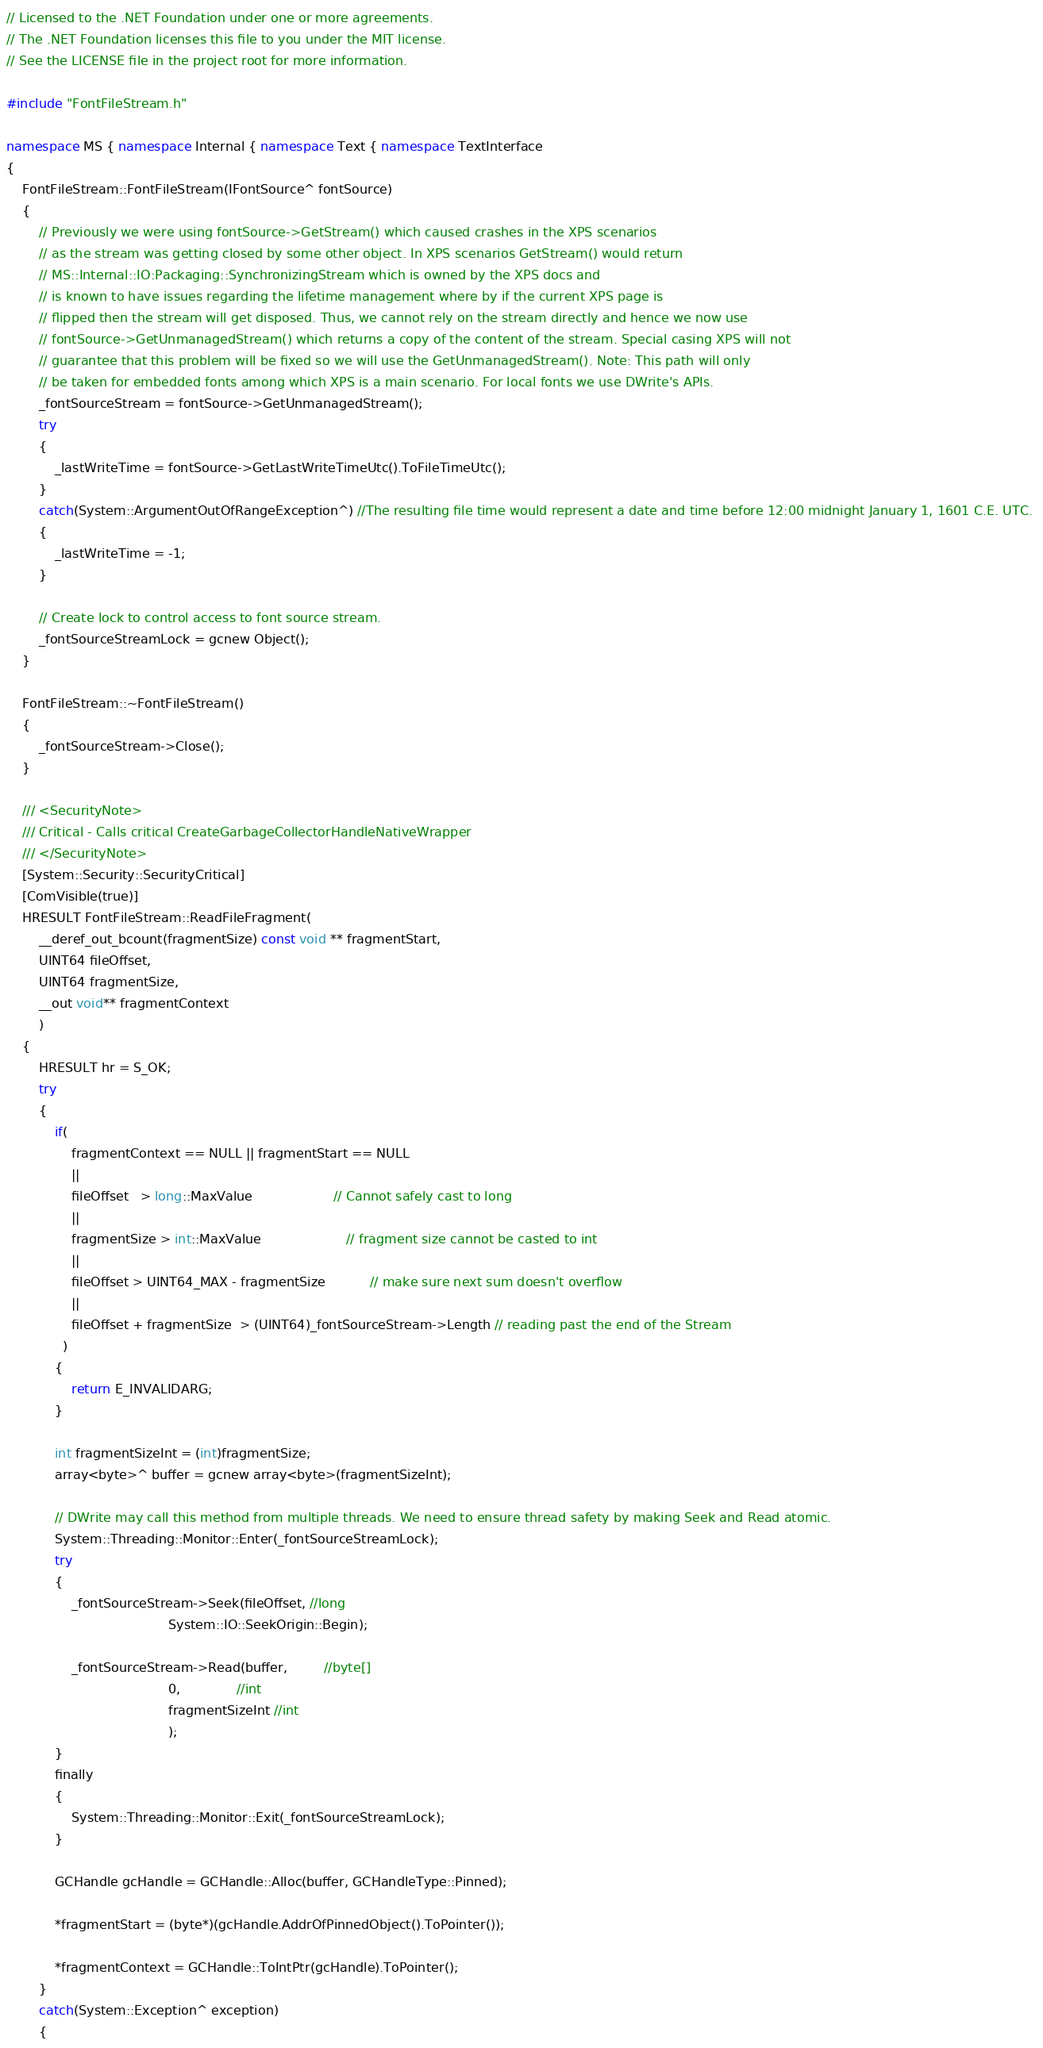<code> <loc_0><loc_0><loc_500><loc_500><_C++_>// Licensed to the .NET Foundation under one or more agreements.
// The .NET Foundation licenses this file to you under the MIT license.
// See the LICENSE file in the project root for more information.

#include "FontFileStream.h"

namespace MS { namespace Internal { namespace Text { namespace TextInterface
{
    FontFileStream::FontFileStream(IFontSource^ fontSource)
    {
        // Previously we were using fontSource->GetStream() which caused crashes in the XPS scenarios
        // as the stream was getting closed by some other object. In XPS scenarios GetStream() would return
        // MS::Internal::IO:Packaging::SynchronizingStream which is owned by the XPS docs and
        // is known to have issues regarding the lifetime management where by if the current XPS page is 
        // flipped then the stream will get disposed. Thus, we cannot rely on the stream directly and hence we now use
        // fontSource->GetUnmanagedStream() which returns a copy of the content of the stream. Special casing XPS will not
        // guarantee that this problem will be fixed so we will use the GetUnmanagedStream(). Note: This path will only 
        // be taken for embedded fonts among which XPS is a main scenario. For local fonts we use DWrite's APIs.
        _fontSourceStream = fontSource->GetUnmanagedStream();
        try
        {
            _lastWriteTime = fontSource->GetLastWriteTimeUtc().ToFileTimeUtc();
        }    
        catch(System::ArgumentOutOfRangeException^) //The resulting file time would represent a date and time before 12:00 midnight January 1, 1601 C.E. UTC. 
        {
            _lastWriteTime = -1;
        }        

        // Create lock to control access to font source stream.
        _fontSourceStreamLock = gcnew Object();
    }

    FontFileStream::~FontFileStream()
    {
        _fontSourceStream->Close();
    }

    /// <SecurityNote>
    /// Critical - Calls critical CreateGarbageCollectorHandleNativeWrapper
    /// </SecurityNote>
    [System::Security::SecurityCritical]
    [ComVisible(true)]
    HRESULT FontFileStream::ReadFileFragment(
        __deref_out_bcount(fragmentSize) const void ** fragmentStart,
        UINT64 fileOffset,
        UINT64 fragmentSize,
        __out void** fragmentContext
        )
    {
        HRESULT hr = S_OK;
        try
        {
            if(
                fragmentContext == NULL || fragmentStart == NULL
                ||
                fileOffset   > long::MaxValue                    // Cannot safely cast to long
                ||            
                fragmentSize > int::MaxValue                     // fragment size cannot be casted to int
                || 
                fileOffset > UINT64_MAX - fragmentSize           // make sure next sum doesn't overflow
                || 
                fileOffset + fragmentSize  > (UINT64)_fontSourceStream->Length // reading past the end of the Stream
              ) 
            {
                return E_INVALIDARG;
            }

            int fragmentSizeInt = (int)fragmentSize;
            array<byte>^ buffer = gcnew array<byte>(fragmentSizeInt);
            
            // DWrite may call this method from multiple threads. We need to ensure thread safety by making Seek and Read atomic.
            System::Threading::Monitor::Enter(_fontSourceStreamLock);
            try
            {
                _fontSourceStream->Seek(fileOffset, //long
                                        System::IO::SeekOrigin::Begin);

                _fontSourceStream->Read(buffer,         //byte[]
                                        0,              //int
                                        fragmentSizeInt //int
                                        );
            }
            finally 
            {
                System::Threading::Monitor::Exit(_fontSourceStreamLock);
            }

            GCHandle gcHandle = GCHandle::Alloc(buffer, GCHandleType::Pinned);

            *fragmentStart = (byte*)(gcHandle.AddrOfPinnedObject().ToPointer());
            
            *fragmentContext = GCHandle::ToIntPtr(gcHandle).ToPointer();
        }
        catch(System::Exception^ exception)
        {</code> 